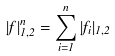<formula> <loc_0><loc_0><loc_500><loc_500>| f | ^ { n } _ { 1 , 2 } = \sum _ { i = 1 } ^ { n } | f _ { i } | _ { 1 , 2 }</formula> 